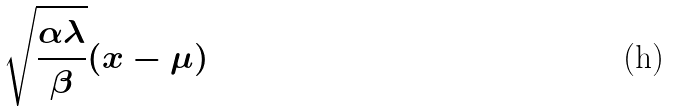<formula> <loc_0><loc_0><loc_500><loc_500>\sqrt { \frac { \alpha \lambda } { \beta } } ( x - \mu )</formula> 